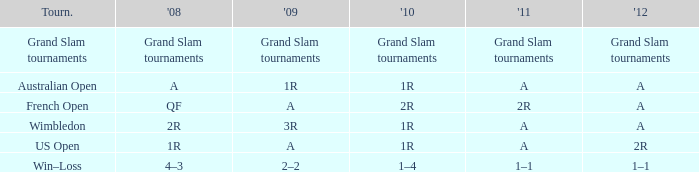Name the 2009 ffor 2010 of 1r and 2012 of a and 2008 of 2r 3R. 